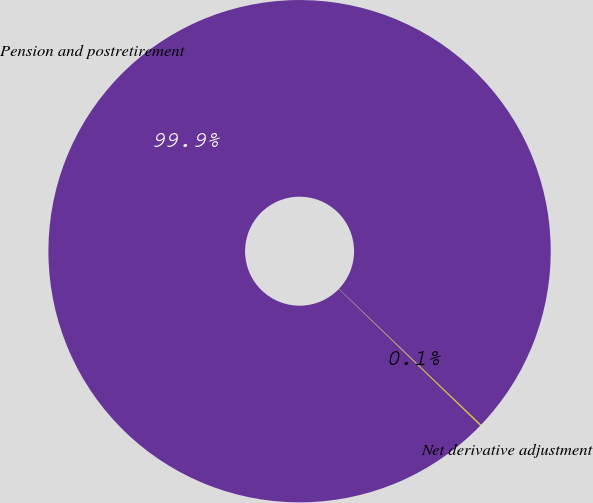Convert chart to OTSL. <chart><loc_0><loc_0><loc_500><loc_500><pie_chart><fcel>Net derivative adjustment<fcel>Pension and postretirement<nl><fcel>0.09%<fcel>99.91%<nl></chart> 